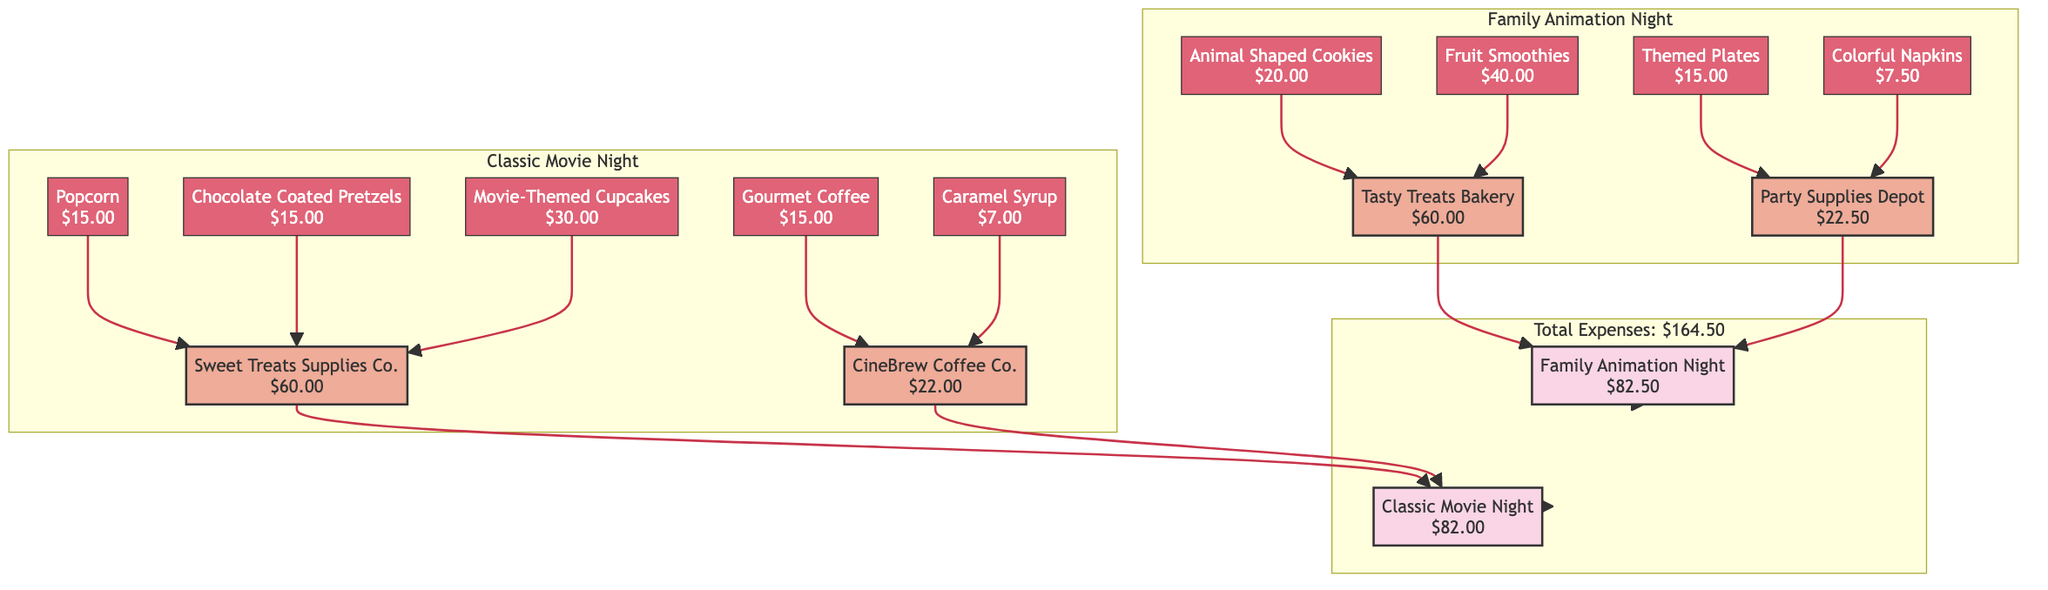What's the total cost of the Classic Movie Night? The total cost of the Classic Movie Night is displayed at the main event node labeled "Classic Movie Night," which shows a total cost of $82.00.
Answer: $82.00 What is the unit cost of the Chocolate Coated Pretzels? The unit cost of the Chocolate Coated Pretzels can be found in the itemized costs of the vendor "Sweet Treats Supplies Co." This is indicated as $3.00 next to the item "Chocolate Coated Pretzels."
Answer: $3.00 How many vendors are involved in the Family Animation Night? The Family Animation Night has two vendors listed within its subgraph: "Tasty Treats Bakery" and "Party Supplies Depot." Therefore, the total count of vendors is 2.
Answer: 2 Which vendor contributed to the most expensive item in the Classic Movie Night? The most expensive item in the Classic Movie Night is "Movie-Themed Cupcakes" with a total cost of $30.00. This item is supplied by the vendor "Sweet Treats Supplies Co."
Answer: Sweet Treats Supplies Co What is the combined total cost of items from Tasty Treats Bakery? The combined total cost of items from "Tasty Treats Bakery" can be calculated by adding the individual total costs of "Animal Shaped Cookies" ($20.00) and "Fruit Smoothies" ($40.00), resulting in $60.00.
Answer: $60.00 How is the total expense of $164.50 derived? The total expense of $164.50 is the sum of the individual total event costs, which are $82.00 from the Classic Movie Night and $82.50 from the Family Animation Night, added together (82.00 + 82.50 = 164.50).
Answer: $164.50 Which event has the vendor "CineBrew Coffee Co."? The vendor "CineBrew Coffee Co." is connected to the Classic Movie Night through its items, indicating that it belongs to the event labeled "Classic Movie Night."
Answer: Classic Movie Night What is the total cost associated with Party Supplies Depot? The total cost from "Party Supplies Depot," which provides "Themed Plates" and "Colorful Napkins," is $22.50 as indicated at the vendor node for "Party Supplies Depot."
Answer: $22.50 How many itemized costs are listed for the Family Animation Night? For the Family Animation Night, the itemized costs are presented for four items: "Animal Shaped Cookies," "Fruit Smoothies," "Themed Plates," and "Colorful Napkins." Therefore, there are 4 itemized costs listed.
Answer: 4 